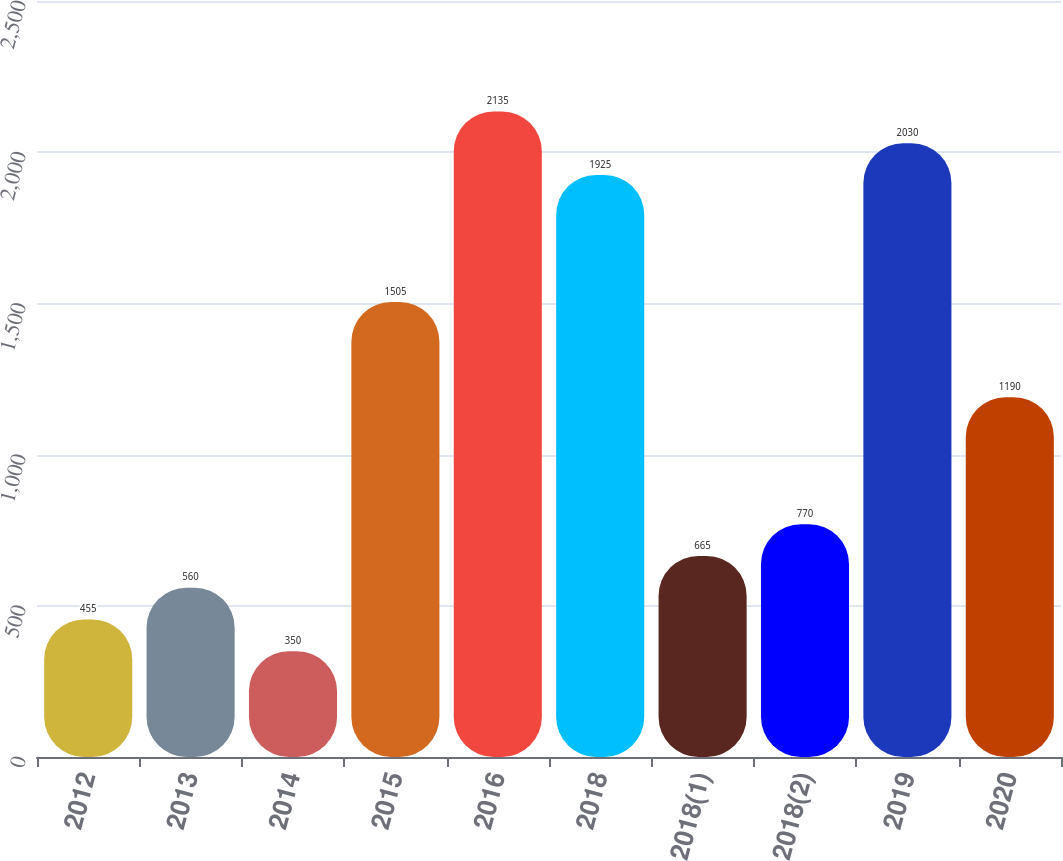Convert chart. <chart><loc_0><loc_0><loc_500><loc_500><bar_chart><fcel>2012<fcel>2013<fcel>2014<fcel>2015<fcel>2016<fcel>2018<fcel>2018(1)<fcel>2018(2)<fcel>2019<fcel>2020<nl><fcel>455<fcel>560<fcel>350<fcel>1505<fcel>2135<fcel>1925<fcel>665<fcel>770<fcel>2030<fcel>1190<nl></chart> 